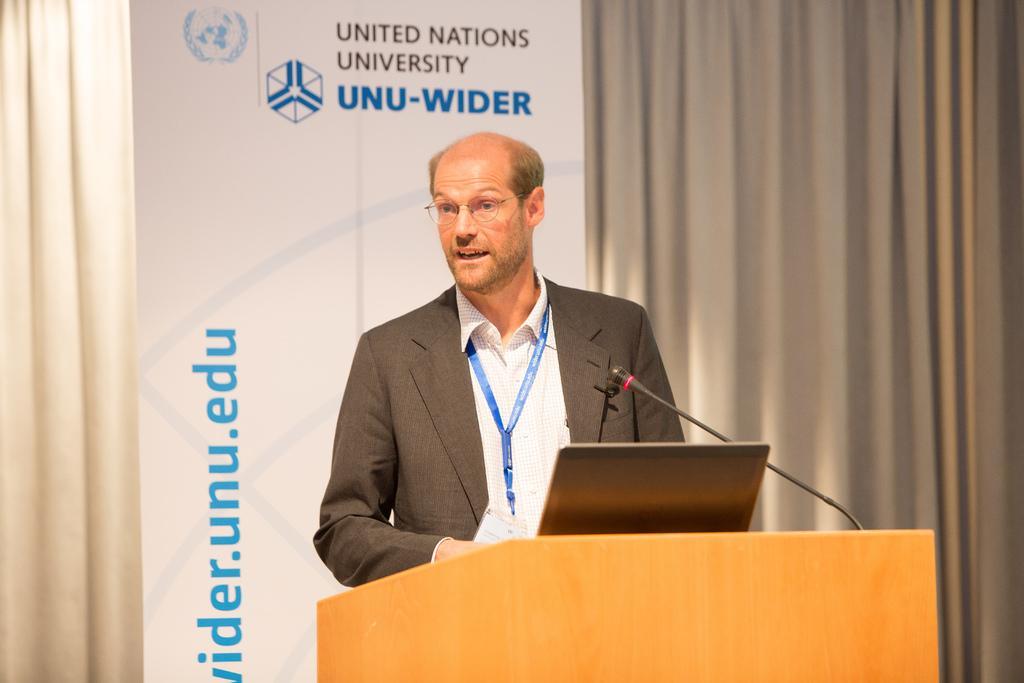Could you give a brief overview of what you see in this image? In this image i can see a man standing wearing a blazer and a badge, there is a podium in front of him,a laptop and a micro phone on the podium, at the back ground i can see, a ash color curtain and a banner in the white color and something written on it. 